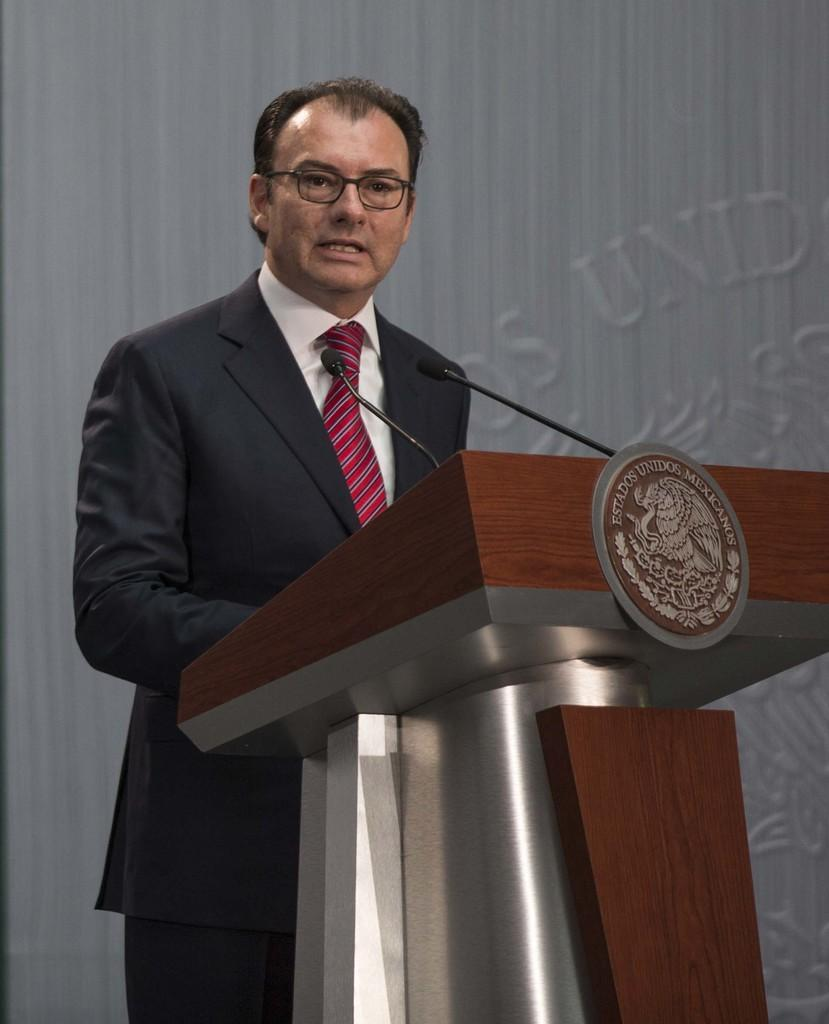What is the man in the image doing? There is a man standing in the image. What object can be seen near the man? There is a podium in the image. How many microphones are visible in the image? There are two microphones in the image. What type of apparatus is the man using to communicate with his father in the hospital? There is no apparatus or reference to a father or hospital in the image; the man is simply standing near a podium with two microphones. 